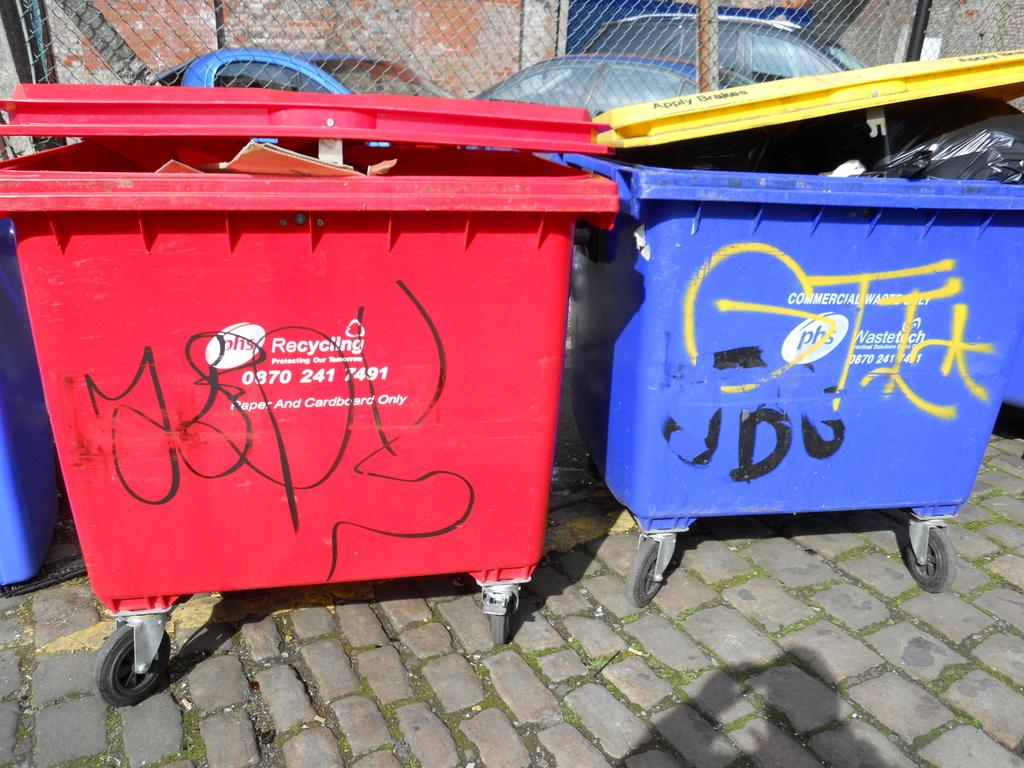<image>
Present a compact description of the photo's key features. A red recycling dumpster and a blue waste dumpster with graffiti on them. 